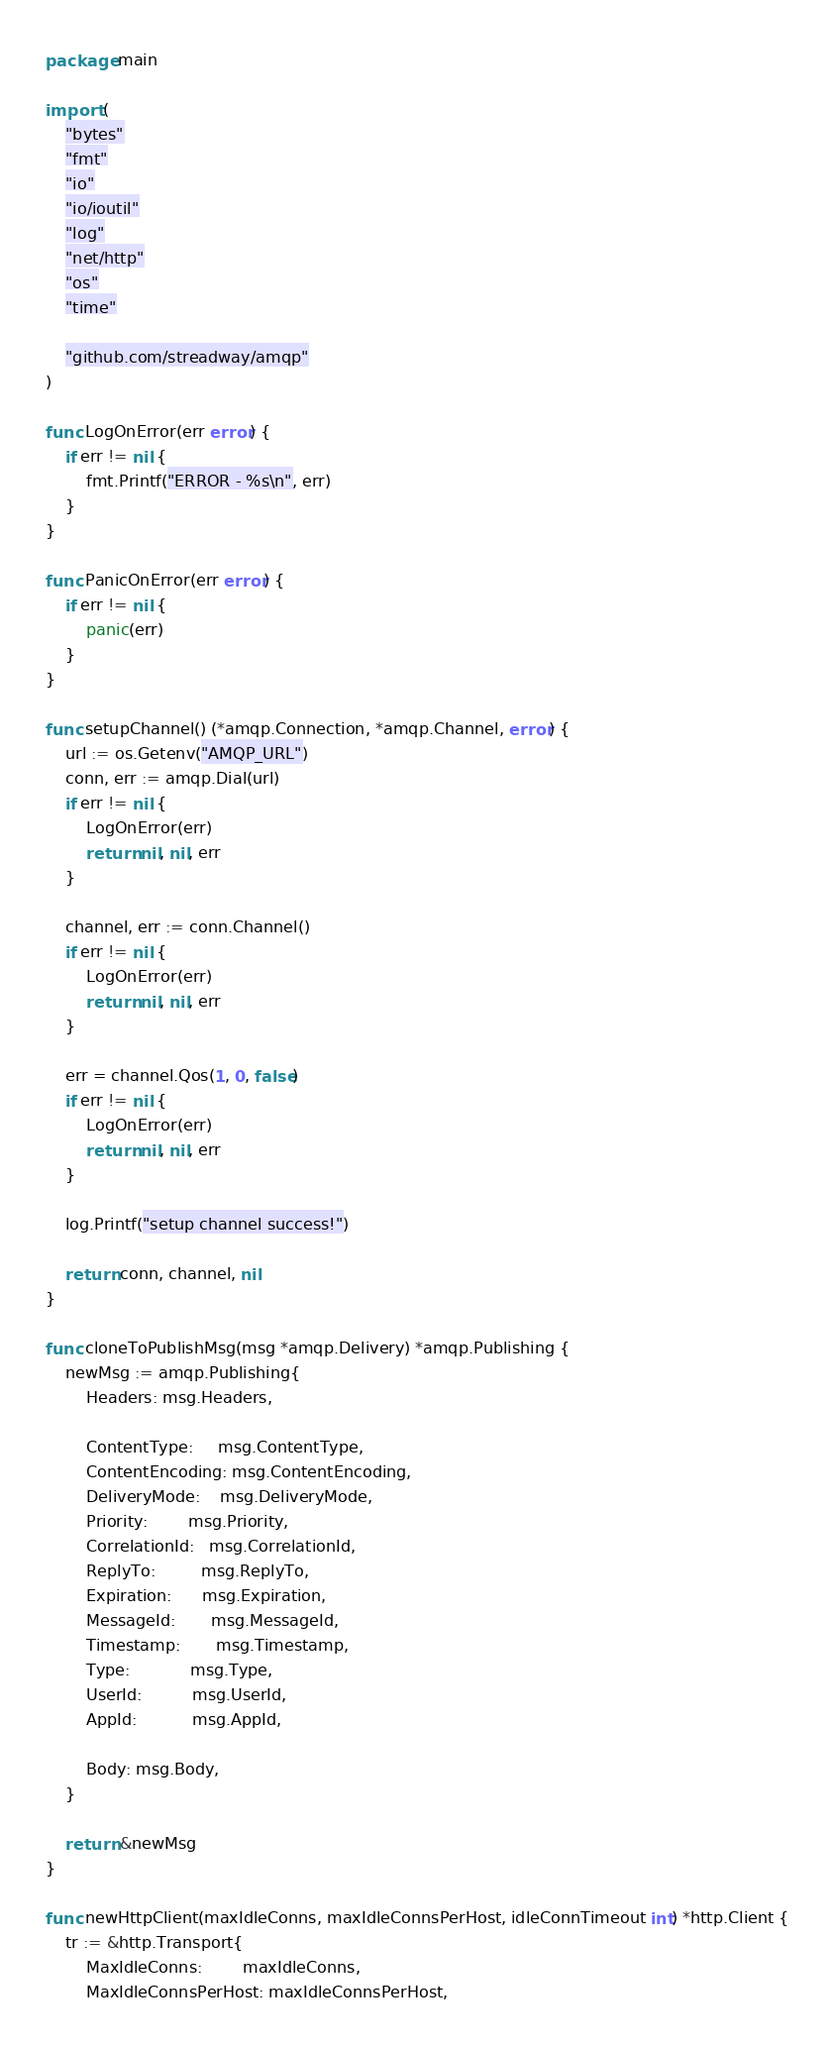Convert code to text. <code><loc_0><loc_0><loc_500><loc_500><_Go_>package main

import (
	"bytes"
	"fmt"
	"io"
	"io/ioutil"
	"log"
	"net/http"
	"os"
	"time"

	"github.com/streadway/amqp"
)

func LogOnError(err error) {
	if err != nil {
		fmt.Printf("ERROR - %s\n", err)
	}
}

func PanicOnError(err error) {
	if err != nil {
		panic(err)
	}
}

func setupChannel() (*amqp.Connection, *amqp.Channel, error) {
	url := os.Getenv("AMQP_URL")
	conn, err := amqp.Dial(url)
	if err != nil {
		LogOnError(err)
		return nil, nil, err
	}

	channel, err := conn.Channel()
	if err != nil {
		LogOnError(err)
		return nil, nil, err
	}

	err = channel.Qos(1, 0, false)
	if err != nil {
		LogOnError(err)
		return nil, nil, err
	}

	log.Printf("setup channel success!")

	return conn, channel, nil
}

func cloneToPublishMsg(msg *amqp.Delivery) *amqp.Publishing {
	newMsg := amqp.Publishing{
		Headers: msg.Headers,

		ContentType:     msg.ContentType,
		ContentEncoding: msg.ContentEncoding,
		DeliveryMode:    msg.DeliveryMode,
		Priority:        msg.Priority,
		CorrelationId:   msg.CorrelationId,
		ReplyTo:         msg.ReplyTo,
		Expiration:      msg.Expiration,
		MessageId:       msg.MessageId,
		Timestamp:       msg.Timestamp,
		Type:            msg.Type,
		UserId:          msg.UserId,
		AppId:           msg.AppId,

		Body: msg.Body,
	}

	return &newMsg
}

func newHttpClient(maxIdleConns, maxIdleConnsPerHost, idleConnTimeout int) *http.Client {
	tr := &http.Transport{
		MaxIdleConns:        maxIdleConns,
		MaxIdleConnsPerHost: maxIdleConnsPerHost,</code> 